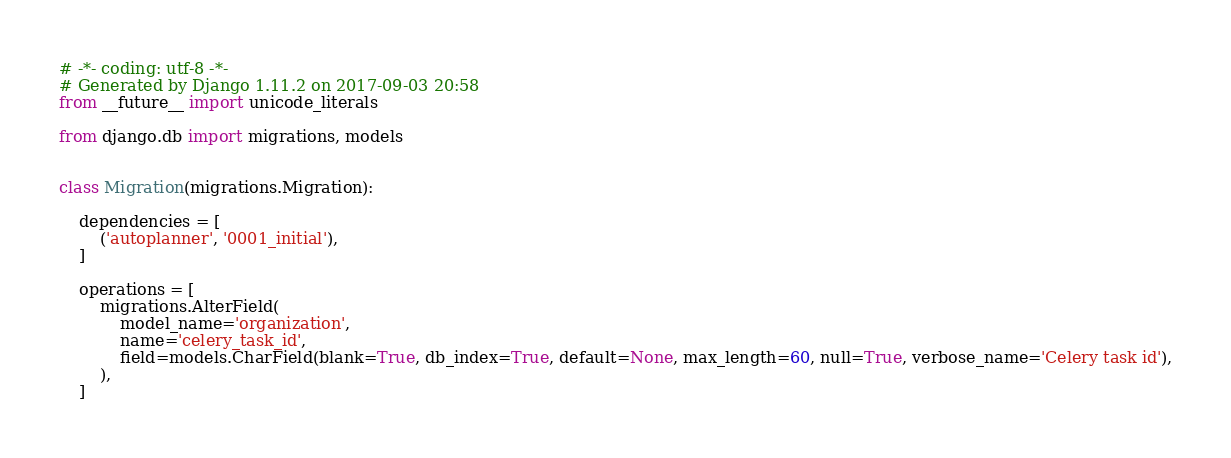Convert code to text. <code><loc_0><loc_0><loc_500><loc_500><_Python_># -*- coding: utf-8 -*-
# Generated by Django 1.11.2 on 2017-09-03 20:58
from __future__ import unicode_literals

from django.db import migrations, models


class Migration(migrations.Migration):

    dependencies = [
        ('autoplanner', '0001_initial'),
    ]

    operations = [
        migrations.AlterField(
            model_name='organization',
            name='celery_task_id',
            field=models.CharField(blank=True, db_index=True, default=None, max_length=60, null=True, verbose_name='Celery task id'),
        ),
    ]
</code> 